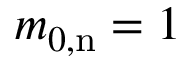Convert formula to latex. <formula><loc_0><loc_0><loc_500><loc_500>m _ { 0 , n } = 1</formula> 